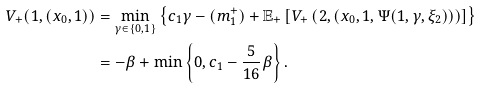Convert formula to latex. <formula><loc_0><loc_0><loc_500><loc_500>V _ { + } ( 1 , ( x _ { 0 } , 1 ) ) & = \min _ { \gamma \in \{ 0 , 1 \} } \left \{ c _ { 1 } \gamma - ( m _ { 1 } ^ { + } ) + \mathbb { E } _ { + } \left [ V _ { + } \left ( 2 , ( x _ { 0 } , 1 , \Psi ( 1 , \gamma , \xi _ { 2 } ) ) \right ) \right ] \right \} \\ & = - \beta + \min \left \{ 0 , c _ { 1 } - \frac { 5 } { 1 6 } \beta \right \} .</formula> 